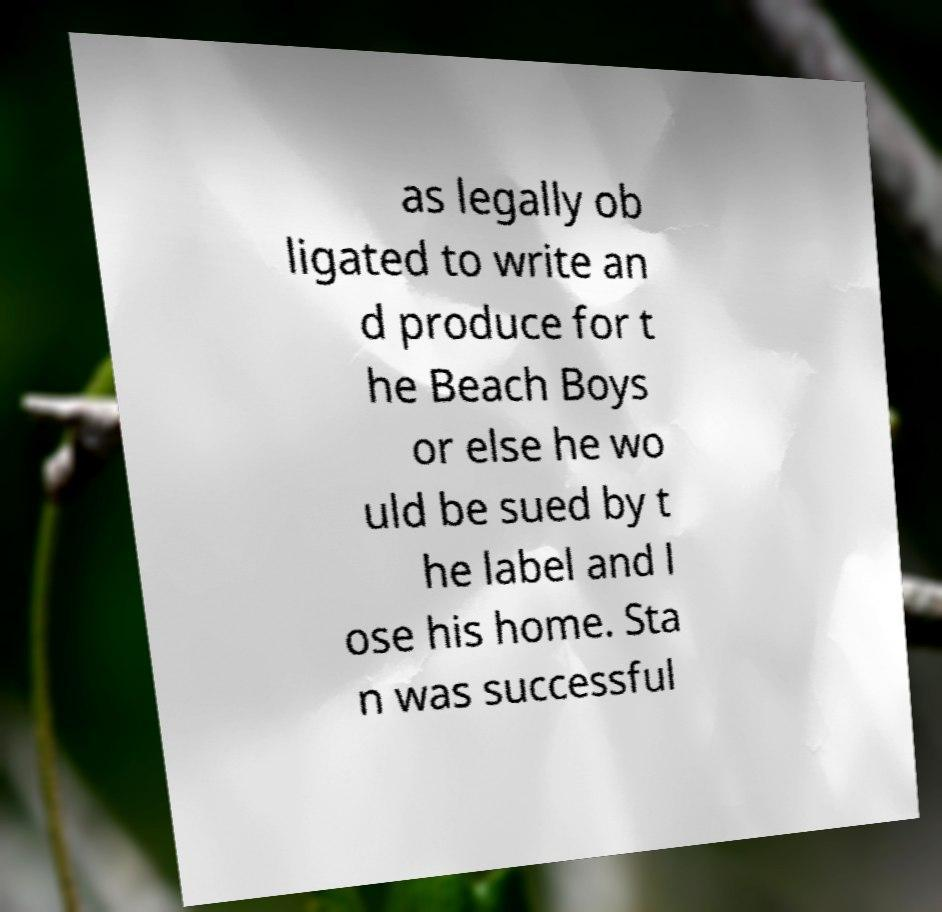Could you assist in decoding the text presented in this image and type it out clearly? as legally ob ligated to write an d produce for t he Beach Boys or else he wo uld be sued by t he label and l ose his home. Sta n was successful 